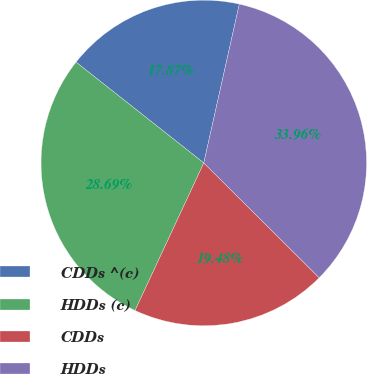<chart> <loc_0><loc_0><loc_500><loc_500><pie_chart><fcel>CDDs ^(c)<fcel>HDDs (c)<fcel>CDDs<fcel>HDDs<nl><fcel>17.87%<fcel>28.69%<fcel>19.48%<fcel>33.96%<nl></chart> 